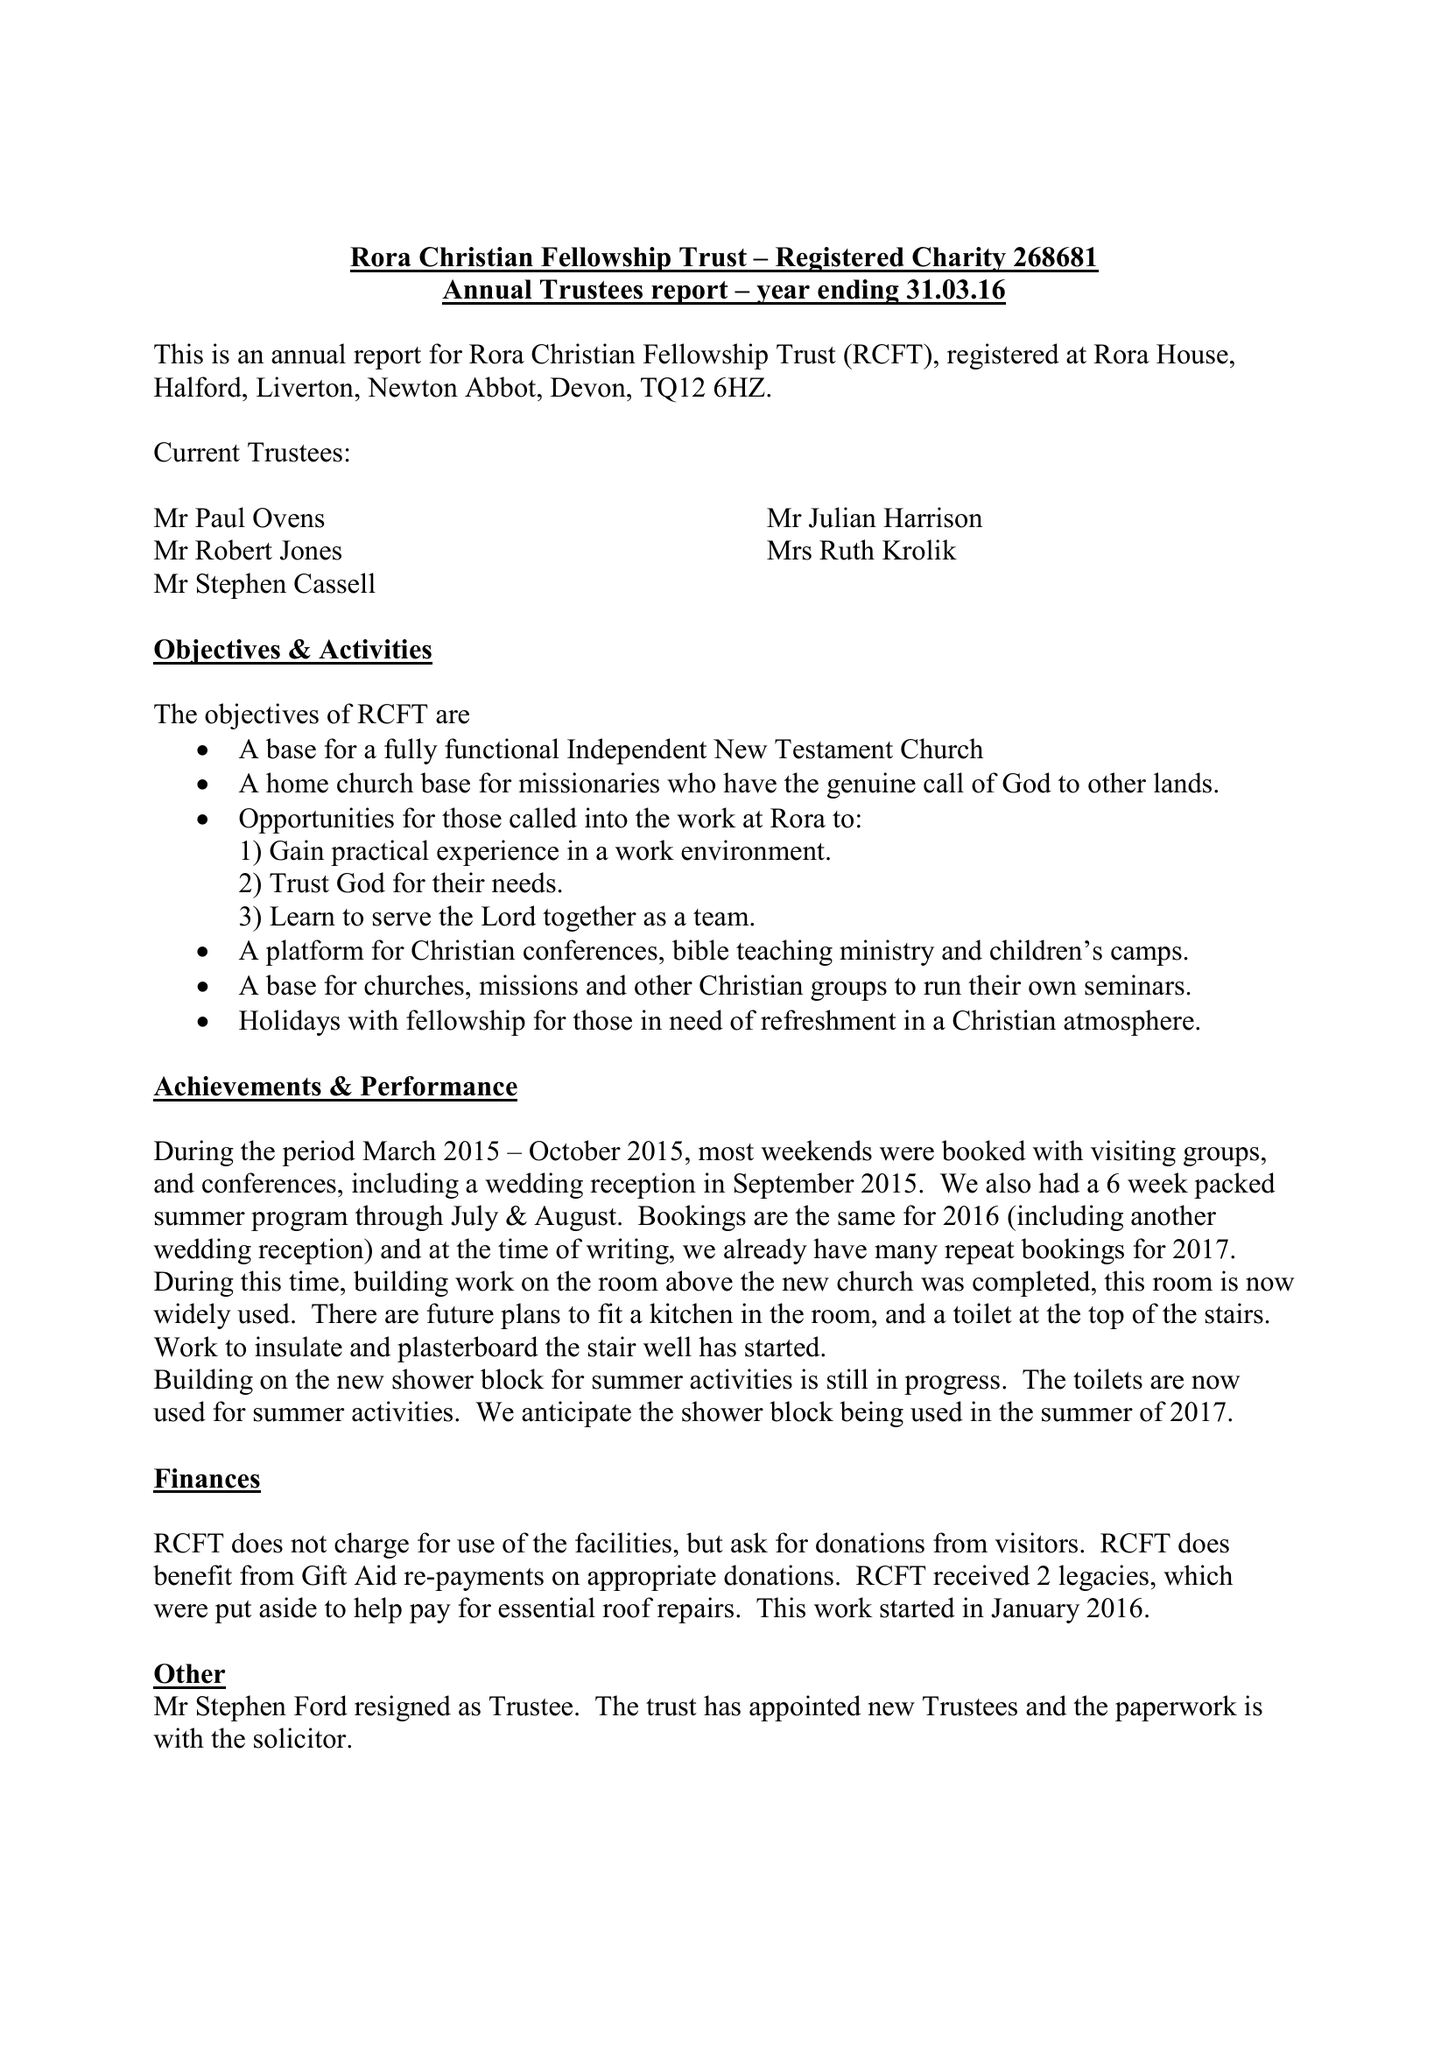What is the value for the income_annually_in_british_pounds?
Answer the question using a single word or phrase. 120714.00 